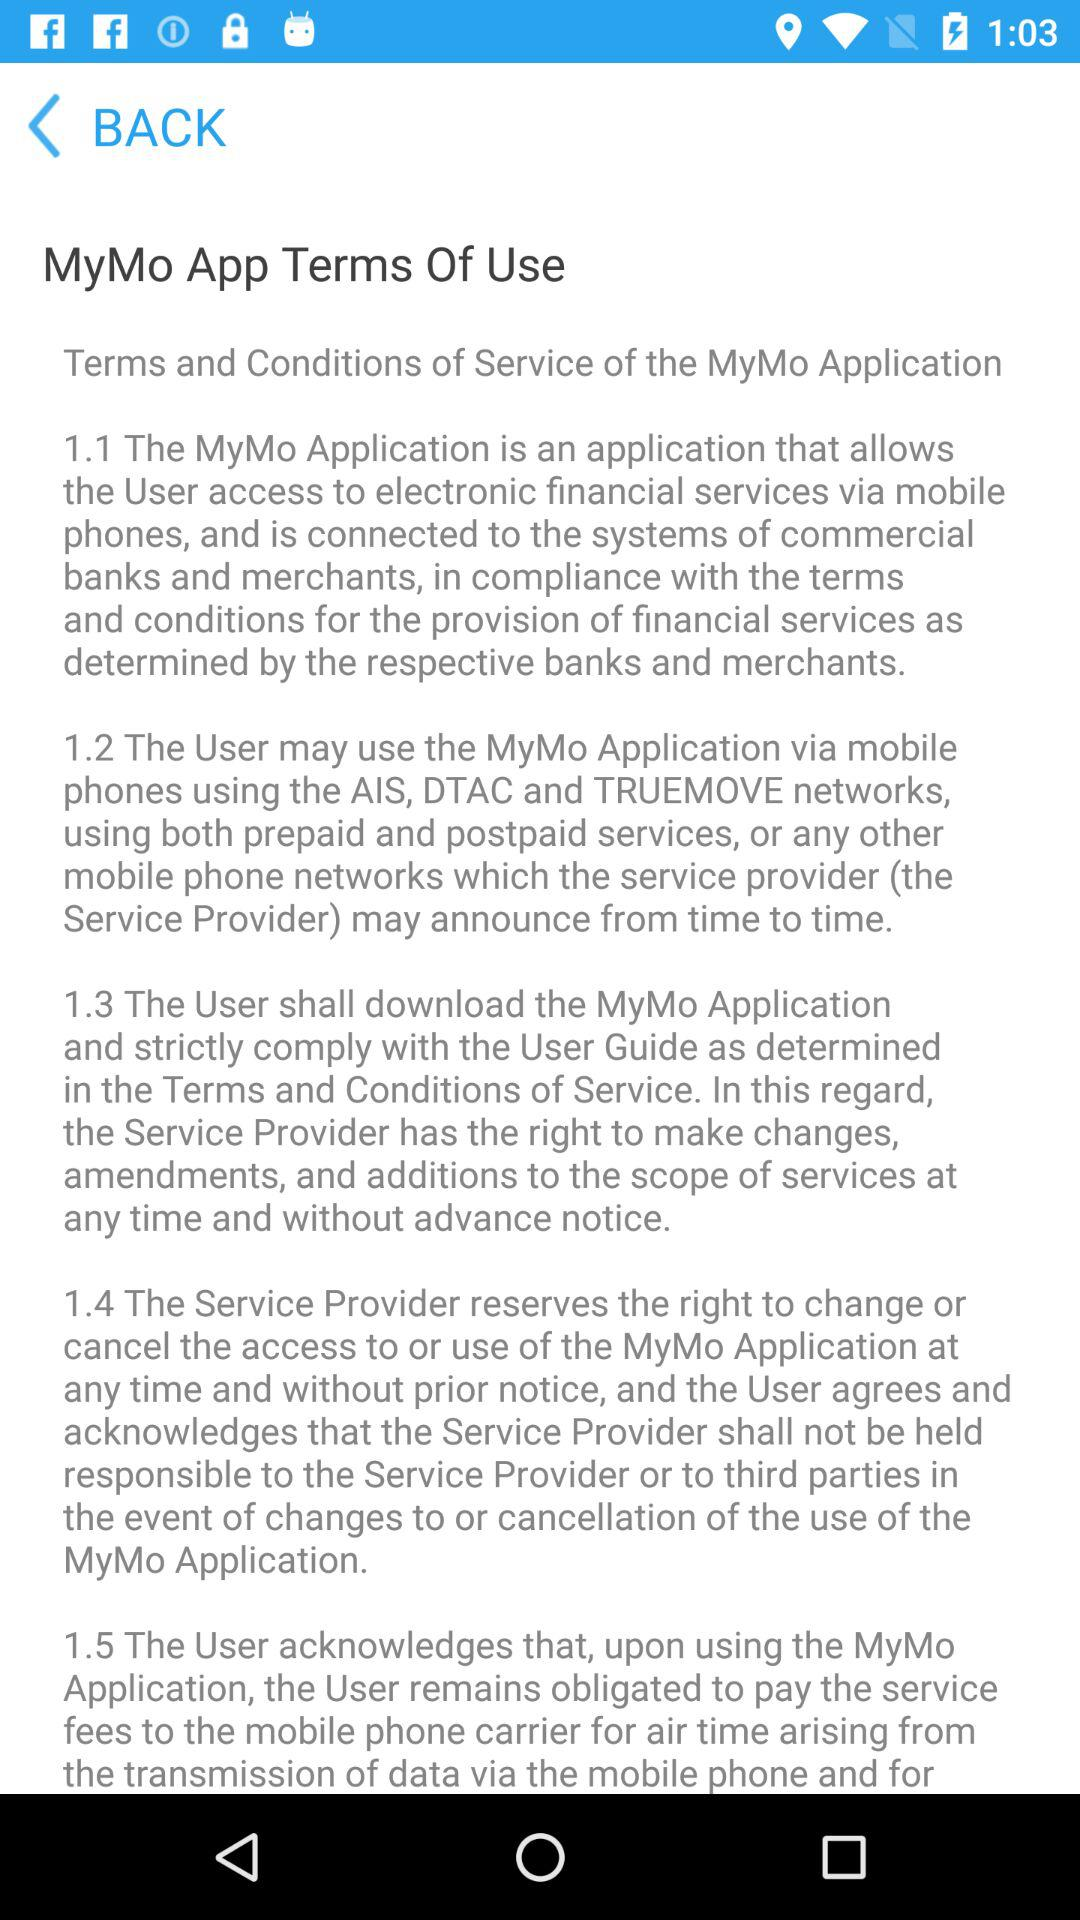How many sections are there in the Terms of Use?
Answer the question using a single word or phrase. 5 